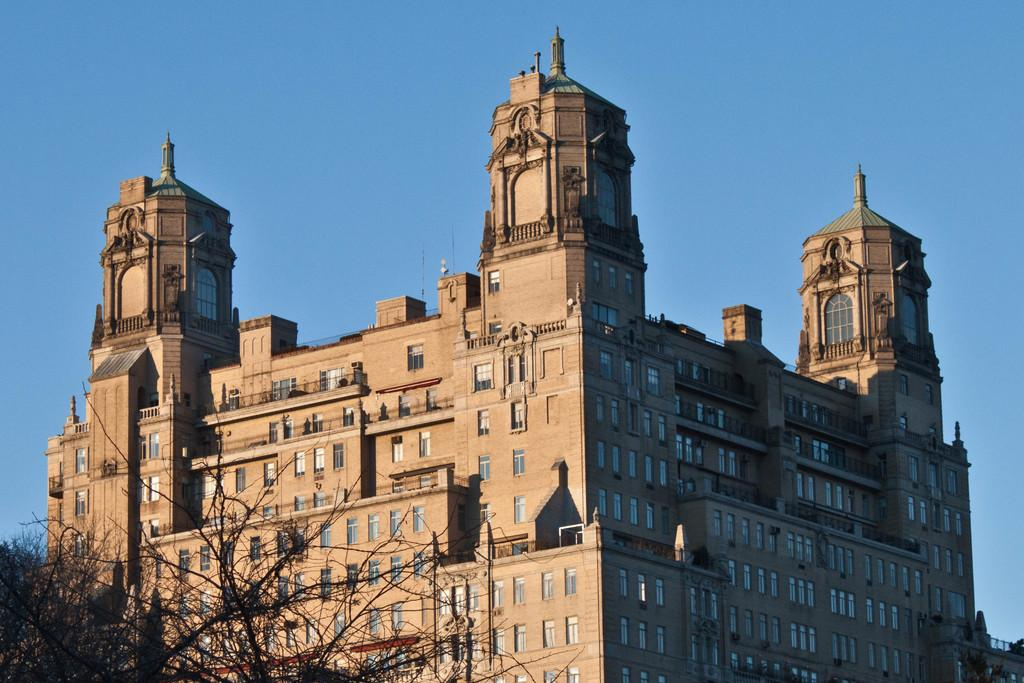What type of structure is present in the image? There is a building in the image. What feature can be seen on the building? The building has windows. What type of vegetation is on the left side of the image? There is a tree on the left side of the image. What is visible at the top of the image? The sky is visible at the top of the image. What is the doctor's opinion on the flight in the image? There is no doctor or flight present in the image, so it is not possible to determine the doctor's opinion on the flight. 